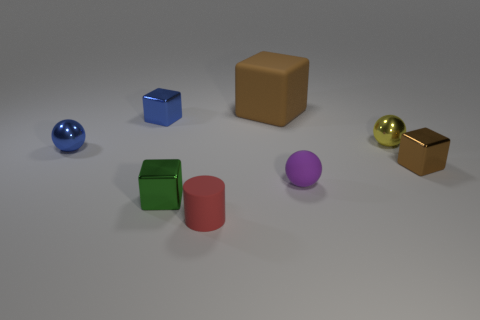What number of other cubes are the same color as the matte block?
Your answer should be compact. 1. Is the color of the big object the same as the sphere to the left of the small purple rubber thing?
Your response must be concise. No. There is a thing that is both to the left of the small red matte cylinder and behind the blue shiny sphere; what is its shape?
Keep it short and to the point. Cube. What is the tiny thing that is behind the yellow metallic thing right of the green thing left of the brown rubber object made of?
Offer a terse response. Metal. Is the number of small purple objects that are to the right of the tiny purple object greater than the number of small things on the left side of the small cylinder?
Your answer should be compact. No. How many balls have the same material as the cylinder?
Your response must be concise. 1. There is a tiny purple matte thing right of the small blue ball; does it have the same shape as the brown object that is behind the small brown metallic cube?
Ensure brevity in your answer.  No. There is a tiny cube behind the blue metal sphere; what color is it?
Offer a terse response. Blue. Is there a big brown matte thing that has the same shape as the tiny yellow thing?
Your answer should be compact. No. What is the material of the tiny green object?
Make the answer very short. Metal. 